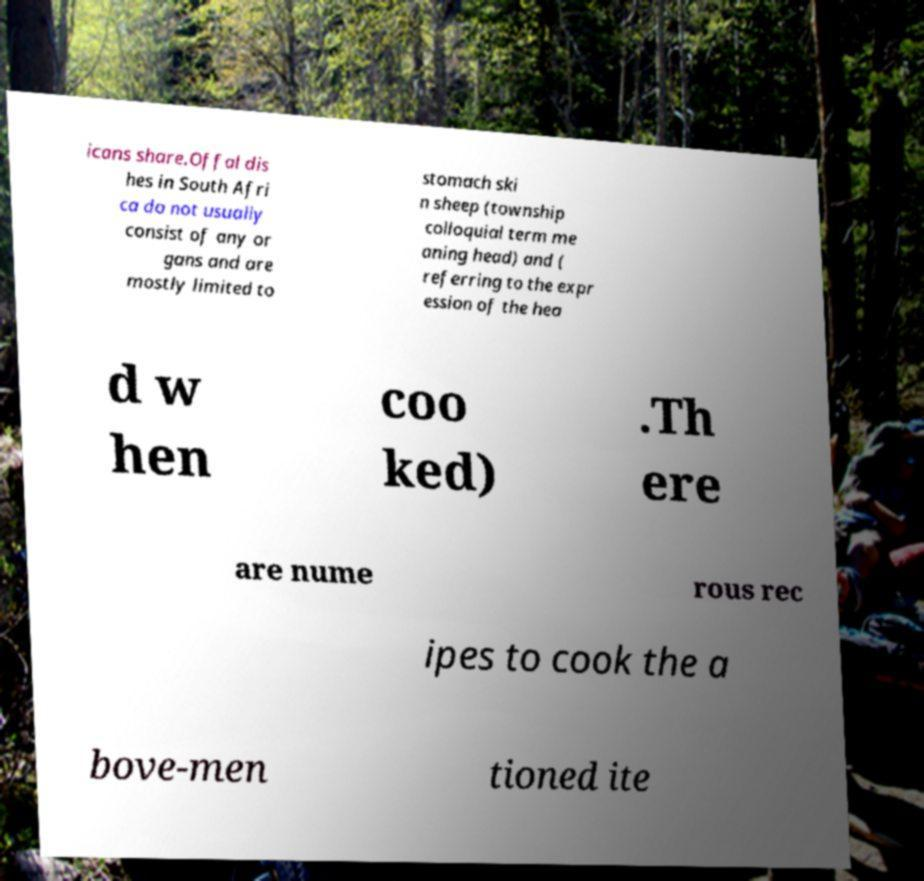Can you accurately transcribe the text from the provided image for me? icans share.Offal dis hes in South Afri ca do not usually consist of any or gans and are mostly limited to stomach ski n sheep (township colloquial term me aning head) and ( referring to the expr ession of the hea d w hen coo ked) .Th ere are nume rous rec ipes to cook the a bove-men tioned ite 